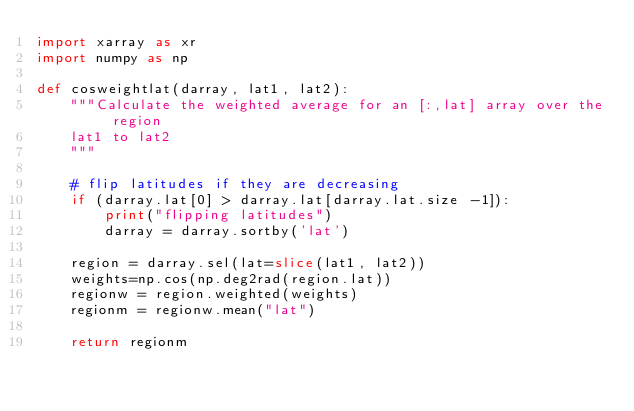<code> <loc_0><loc_0><loc_500><loc_500><_Python_>import xarray as xr
import numpy as np

def cosweightlat(darray, lat1, lat2):
    """Calculate the weighted average for an [:,lat] array over the region
    lat1 to lat2
    """

    # flip latitudes if they are decreasing
    if (darray.lat[0] > darray.lat[darray.lat.size -1]):
        print("flipping latitudes")
        darray = darray.sortby('lat')

    region = darray.sel(lat=slice(lat1, lat2))
    weights=np.cos(np.deg2rad(region.lat))
    regionw = region.weighted(weights)
    regionm = regionw.mean("lat")

    return regionm
</code> 